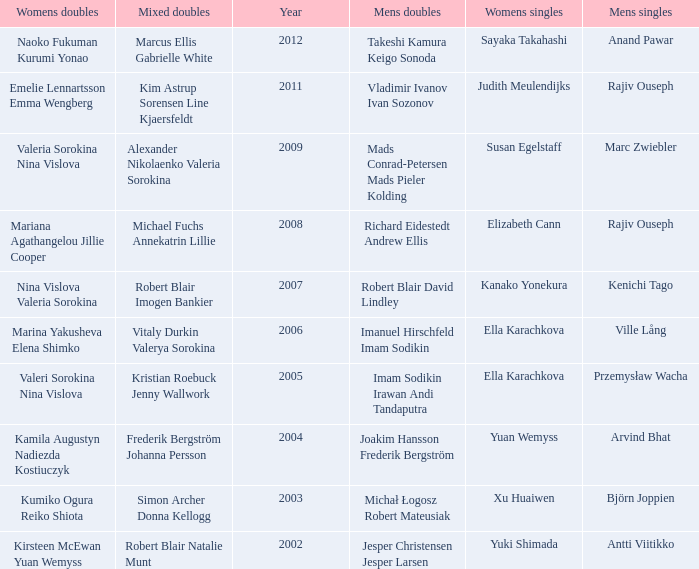What are the womens singles of naoko fukuman kurumi yonao? Sayaka Takahashi. 